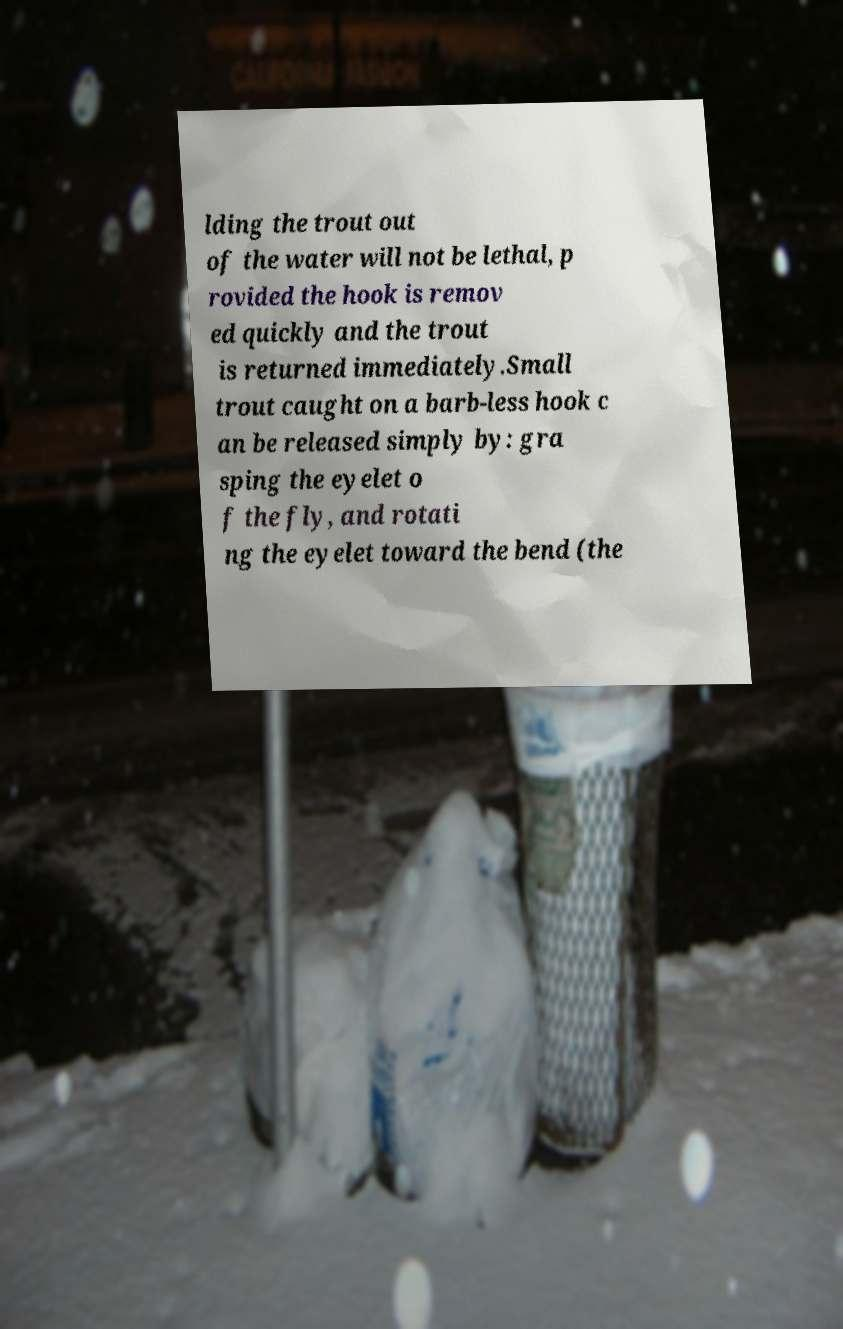Can you accurately transcribe the text from the provided image for me? lding the trout out of the water will not be lethal, p rovided the hook is remov ed quickly and the trout is returned immediately.Small trout caught on a barb-less hook c an be released simply by: gra sping the eyelet o f the fly, and rotati ng the eyelet toward the bend (the 